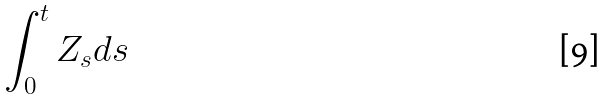<formula> <loc_0><loc_0><loc_500><loc_500>\int _ { 0 } ^ { t } Z _ { s } d s</formula> 